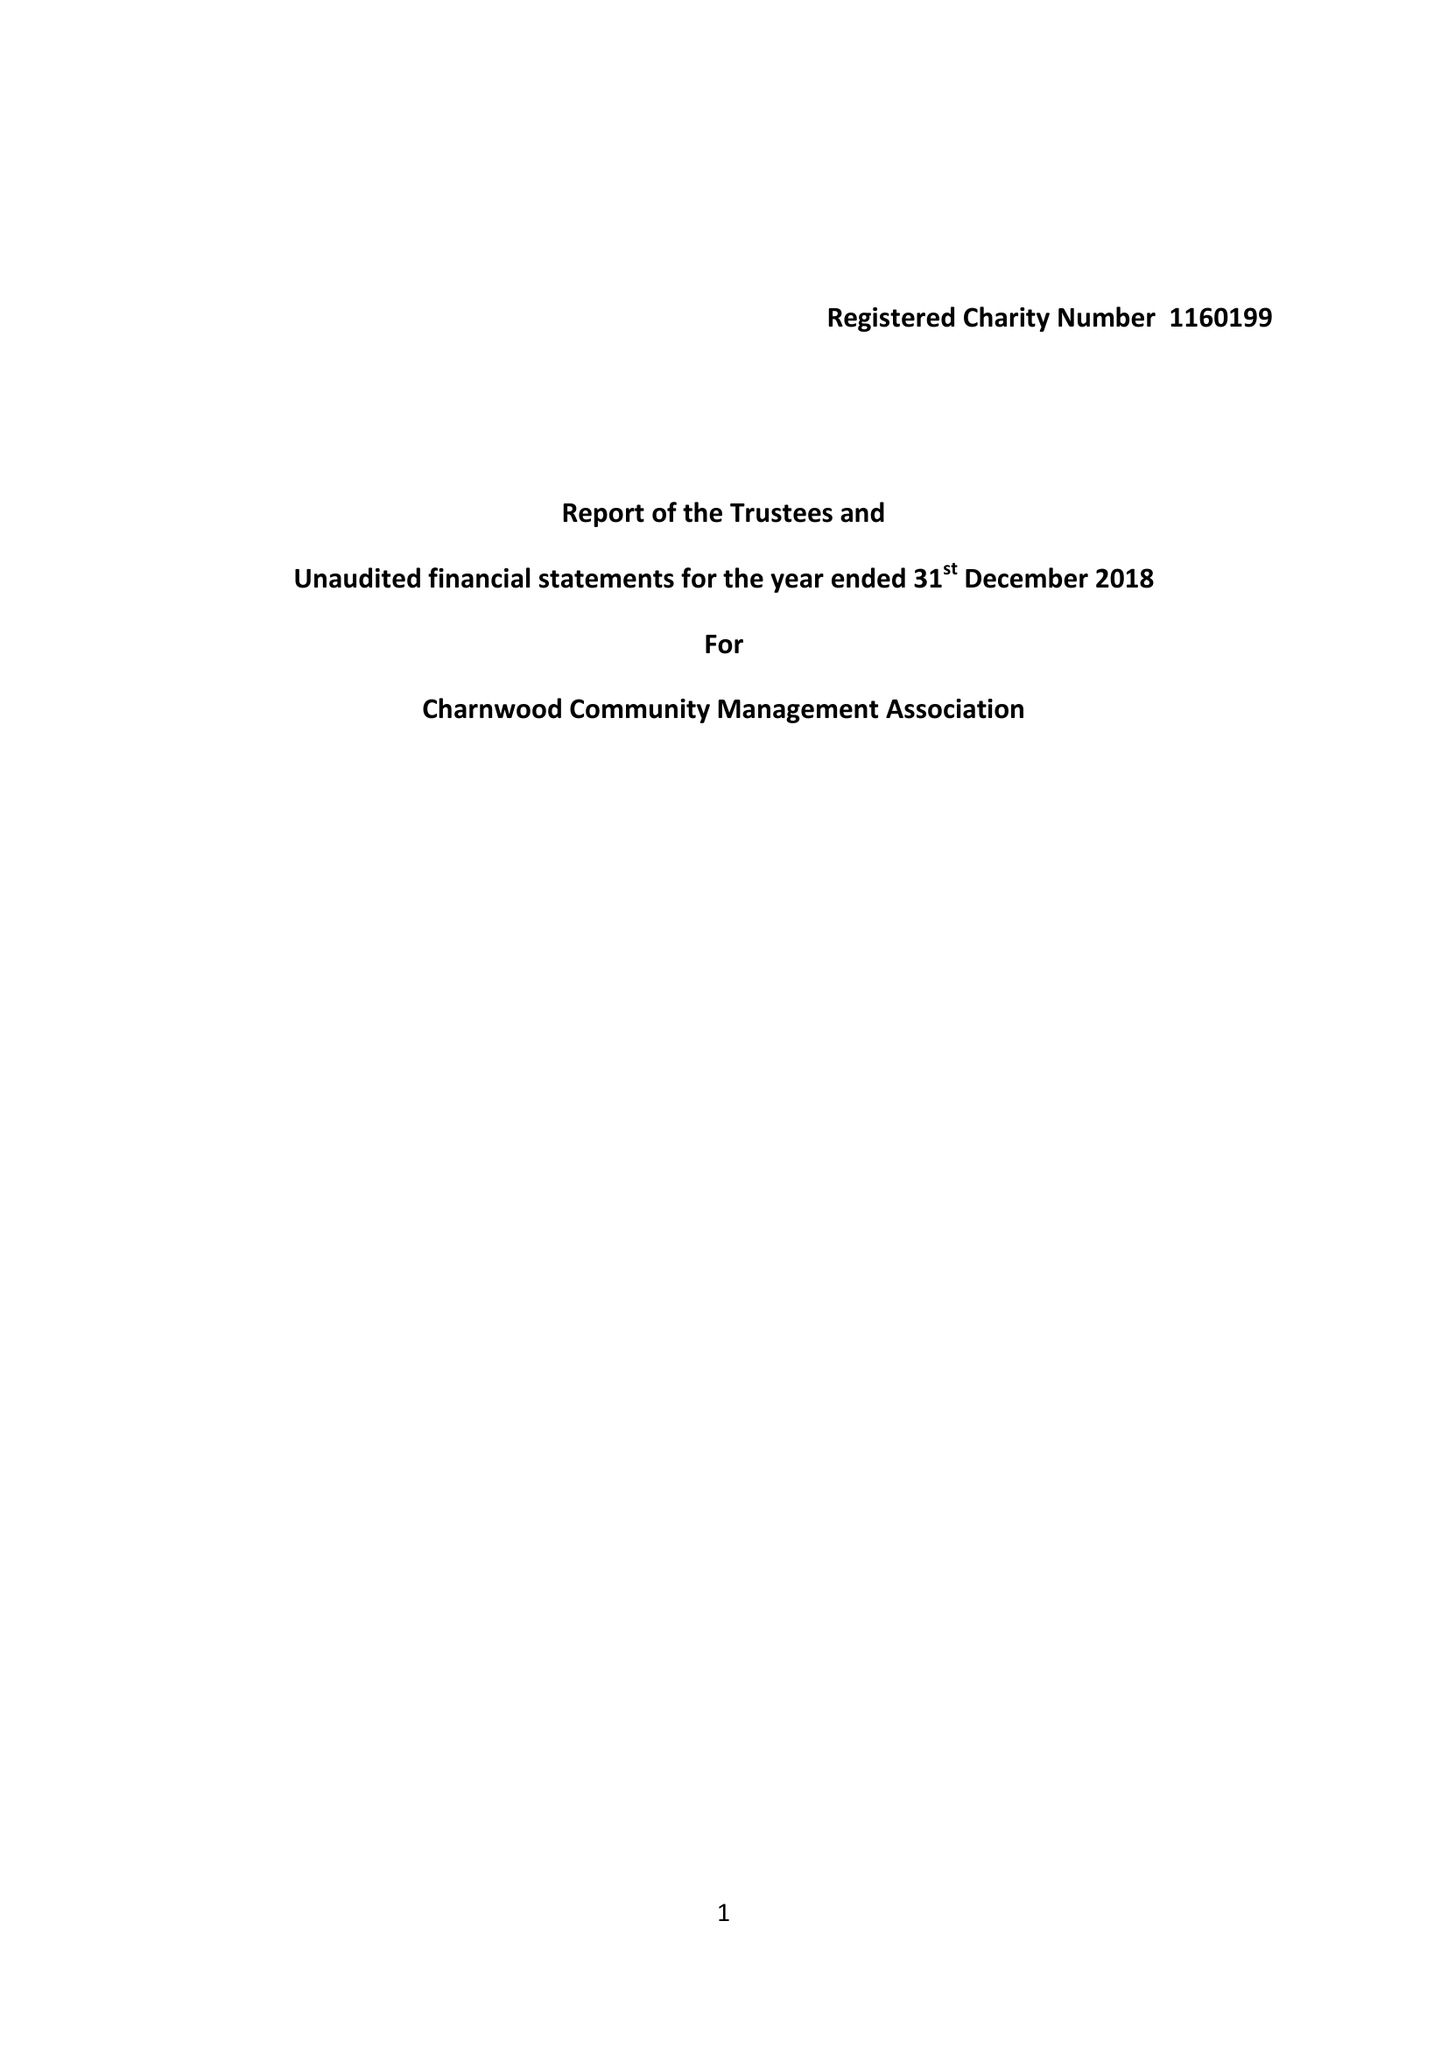What is the value for the address__postcode?
Answer the question using a single word or phrase. SG5 2HZ 